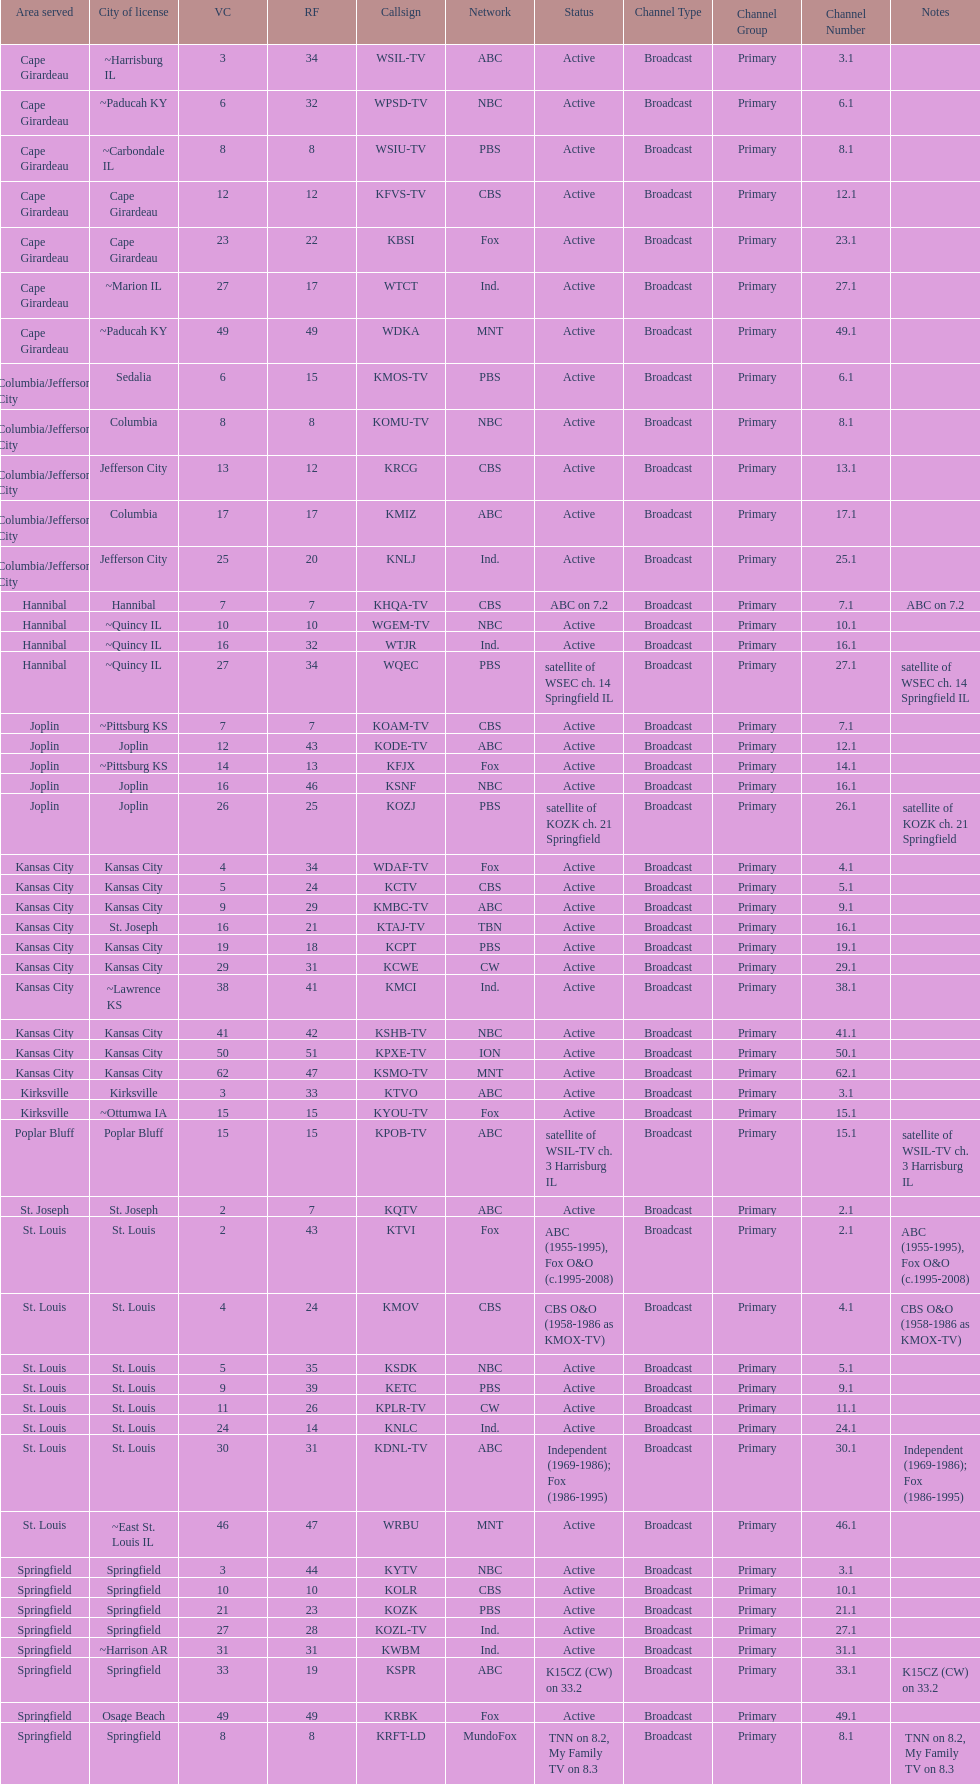Kode-tv and wsil-tv both are a part of which network? ABC. 